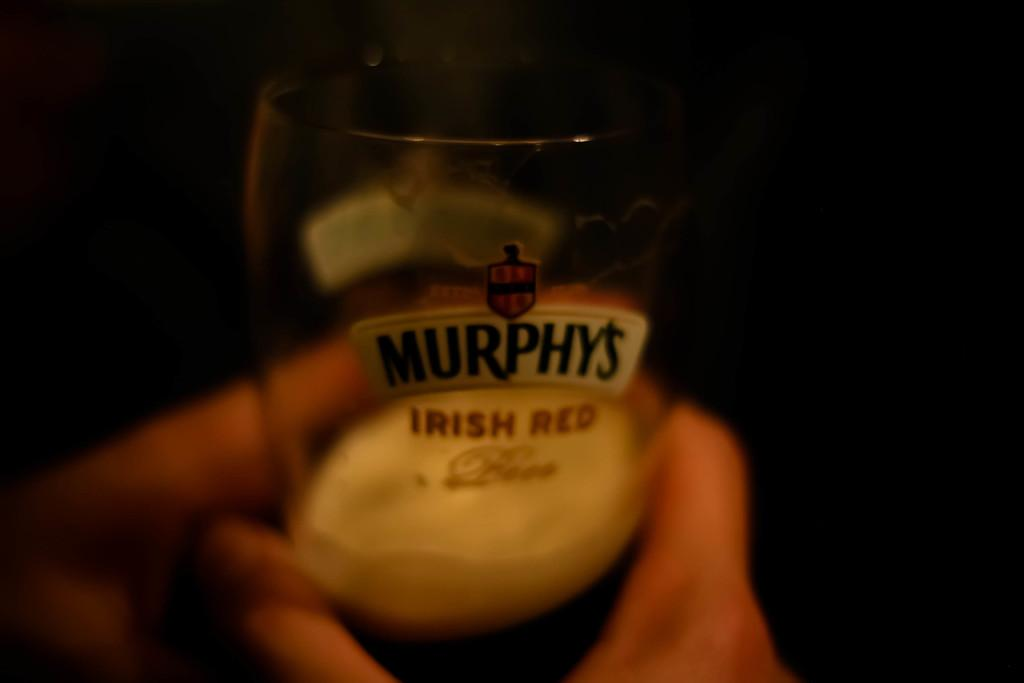<image>
Summarize the visual content of the image. Person holding a Murphy's Irish Red beer cup. 